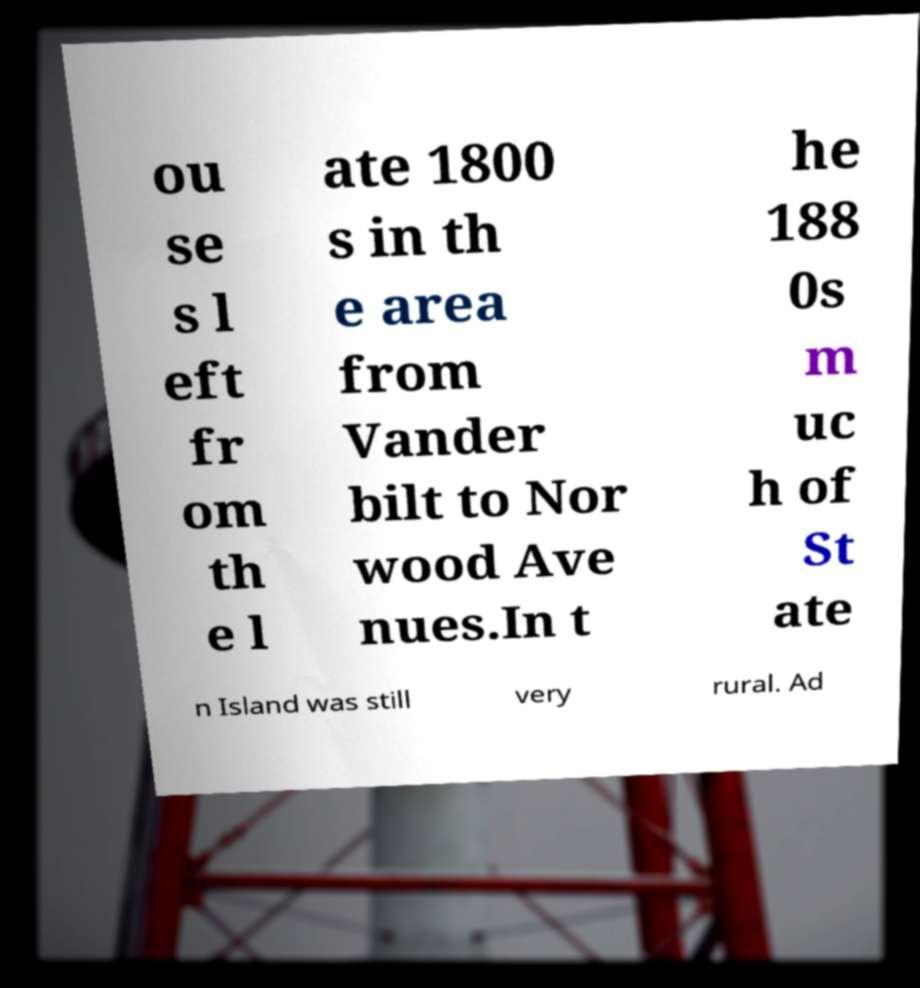There's text embedded in this image that I need extracted. Can you transcribe it verbatim? ou se s l eft fr om th e l ate 1800 s in th e area from Vander bilt to Nor wood Ave nues.In t he 188 0s m uc h of St ate n Island was still very rural. Ad 